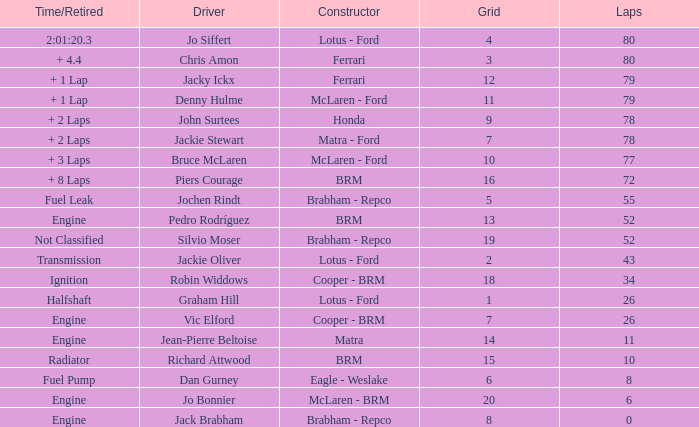When the driver richard attwood has a constructor of brm, what is the number of laps? 10.0. 